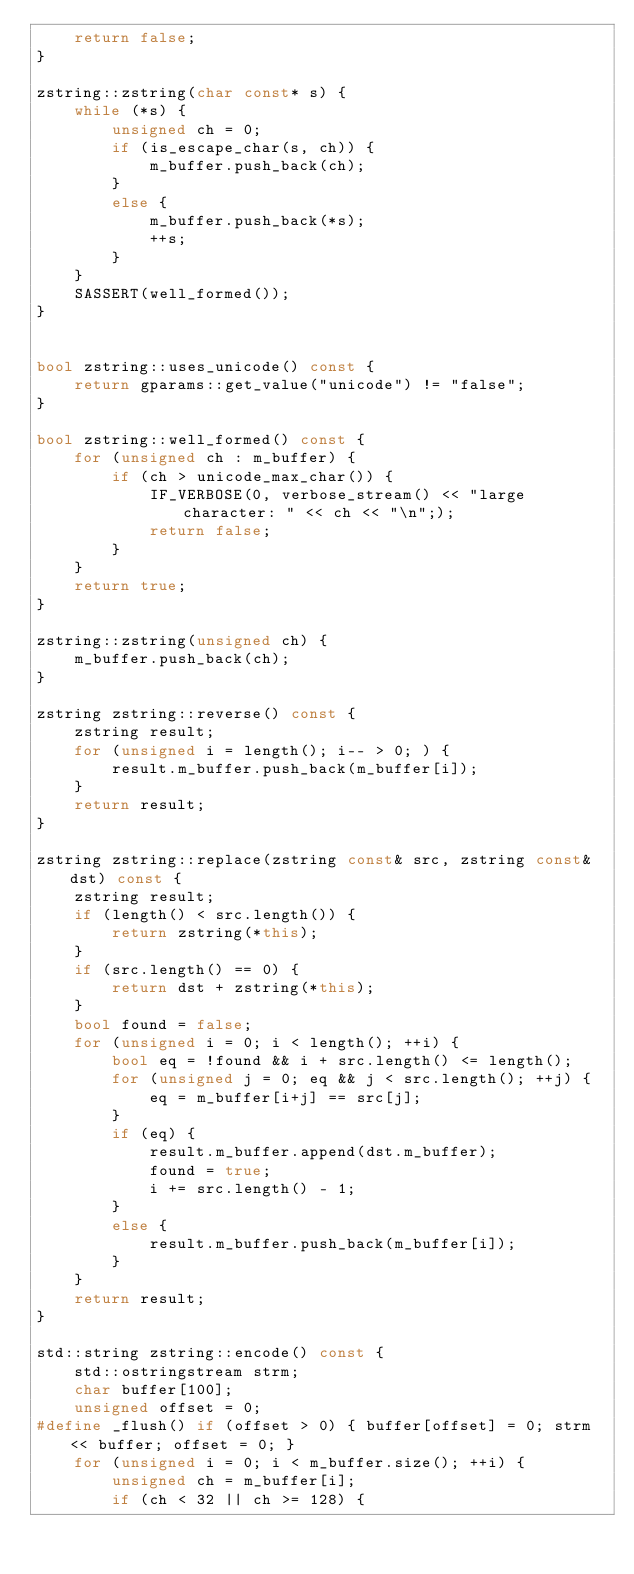<code> <loc_0><loc_0><loc_500><loc_500><_C++_>    return false;
}

zstring::zstring(char const* s) {
    while (*s) {
        unsigned ch = 0;
        if (is_escape_char(s, ch)) {
            m_buffer.push_back(ch);
        }
        else {
            m_buffer.push_back(*s);
            ++s;
        }
    }
    SASSERT(well_formed());
}


bool zstring::uses_unicode() const {
    return gparams::get_value("unicode") != "false";
}

bool zstring::well_formed() const {
    for (unsigned ch : m_buffer) {
        if (ch > unicode_max_char()) {
            IF_VERBOSE(0, verbose_stream() << "large character: " << ch << "\n";);
            return false;
        }
    }
    return true;
}

zstring::zstring(unsigned ch) {
    m_buffer.push_back(ch);
}

zstring zstring::reverse() const {
    zstring result;
    for (unsigned i = length(); i-- > 0; ) {
        result.m_buffer.push_back(m_buffer[i]);
    }
    return result;
}

zstring zstring::replace(zstring const& src, zstring const& dst) const {
    zstring result;
    if (length() < src.length()) {
        return zstring(*this);
    }
    if (src.length() == 0) {
        return dst + zstring(*this);
    }
    bool found = false;
    for (unsigned i = 0; i < length(); ++i) {
        bool eq = !found && i + src.length() <= length();
        for (unsigned j = 0; eq && j < src.length(); ++j) {
            eq = m_buffer[i+j] == src[j];
        }
        if (eq) {
            result.m_buffer.append(dst.m_buffer);
            found = true;
            i += src.length() - 1;
        }
        else {
            result.m_buffer.push_back(m_buffer[i]);
        }
    }
    return result;
}

std::string zstring::encode() const {
    std::ostringstream strm;
    char buffer[100];
    unsigned offset = 0;
#define _flush() if (offset > 0) { buffer[offset] = 0; strm << buffer; offset = 0; }
    for (unsigned i = 0; i < m_buffer.size(); ++i) {
        unsigned ch = m_buffer[i];
        if (ch < 32 || ch >= 128) {</code> 